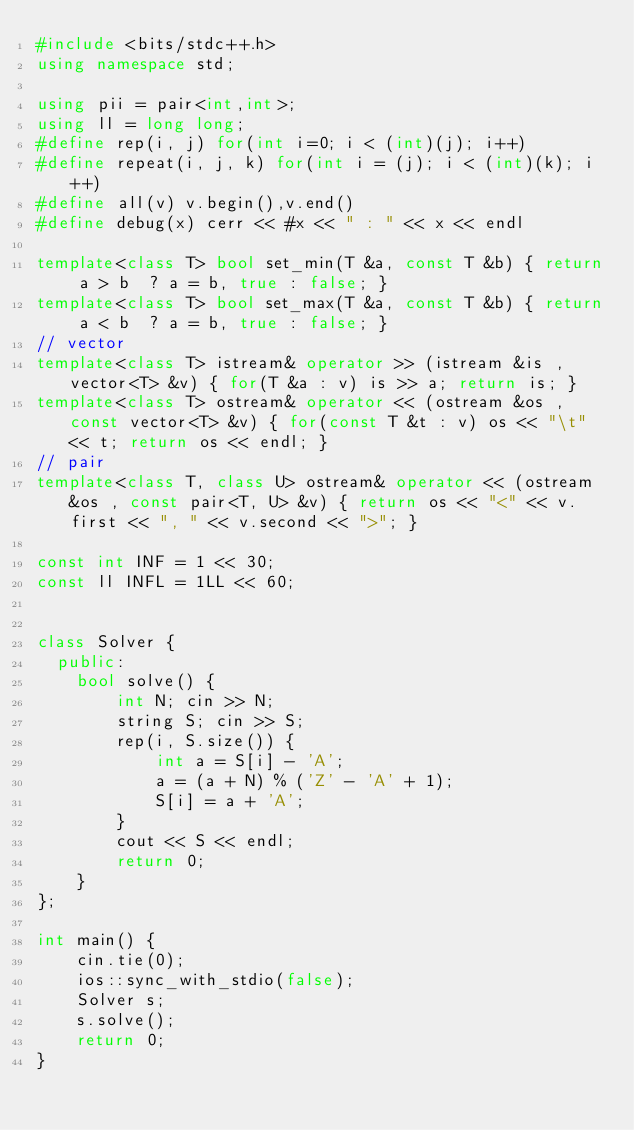<code> <loc_0><loc_0><loc_500><loc_500><_C++_>#include <bits/stdc++.h>
using namespace std;

using pii = pair<int,int>;
using ll = long long;
#define rep(i, j) for(int i=0; i < (int)(j); i++)
#define repeat(i, j, k) for(int i = (j); i < (int)(k); i++)
#define all(v) v.begin(),v.end()
#define debug(x) cerr << #x << " : " << x << endl

template<class T> bool set_min(T &a, const T &b) { return a > b  ? a = b, true : false; }
template<class T> bool set_max(T &a, const T &b) { return a < b  ? a = b, true : false; }
// vector
template<class T> istream& operator >> (istream &is , vector<T> &v) { for(T &a : v) is >> a; return is; }
template<class T> ostream& operator << (ostream &os , const vector<T> &v) { for(const T &t : v) os << "\t" << t; return os << endl; }
// pair
template<class T, class U> ostream& operator << (ostream &os , const pair<T, U> &v) { return os << "<" << v.first << ", " << v.second << ">"; }

const int INF = 1 << 30;
const ll INFL = 1LL << 60;


class Solver {
  public:
    bool solve() {
        int N; cin >> N;
        string S; cin >> S;
        rep(i, S.size()) {
            int a = S[i] - 'A';
            a = (a + N) % ('Z' - 'A' + 1);
            S[i] = a + 'A';
        }
        cout << S << endl;
        return 0;
    }
};

int main() {
    cin.tie(0);
    ios::sync_with_stdio(false);
    Solver s;
    s.solve();
    return 0;
}
</code> 